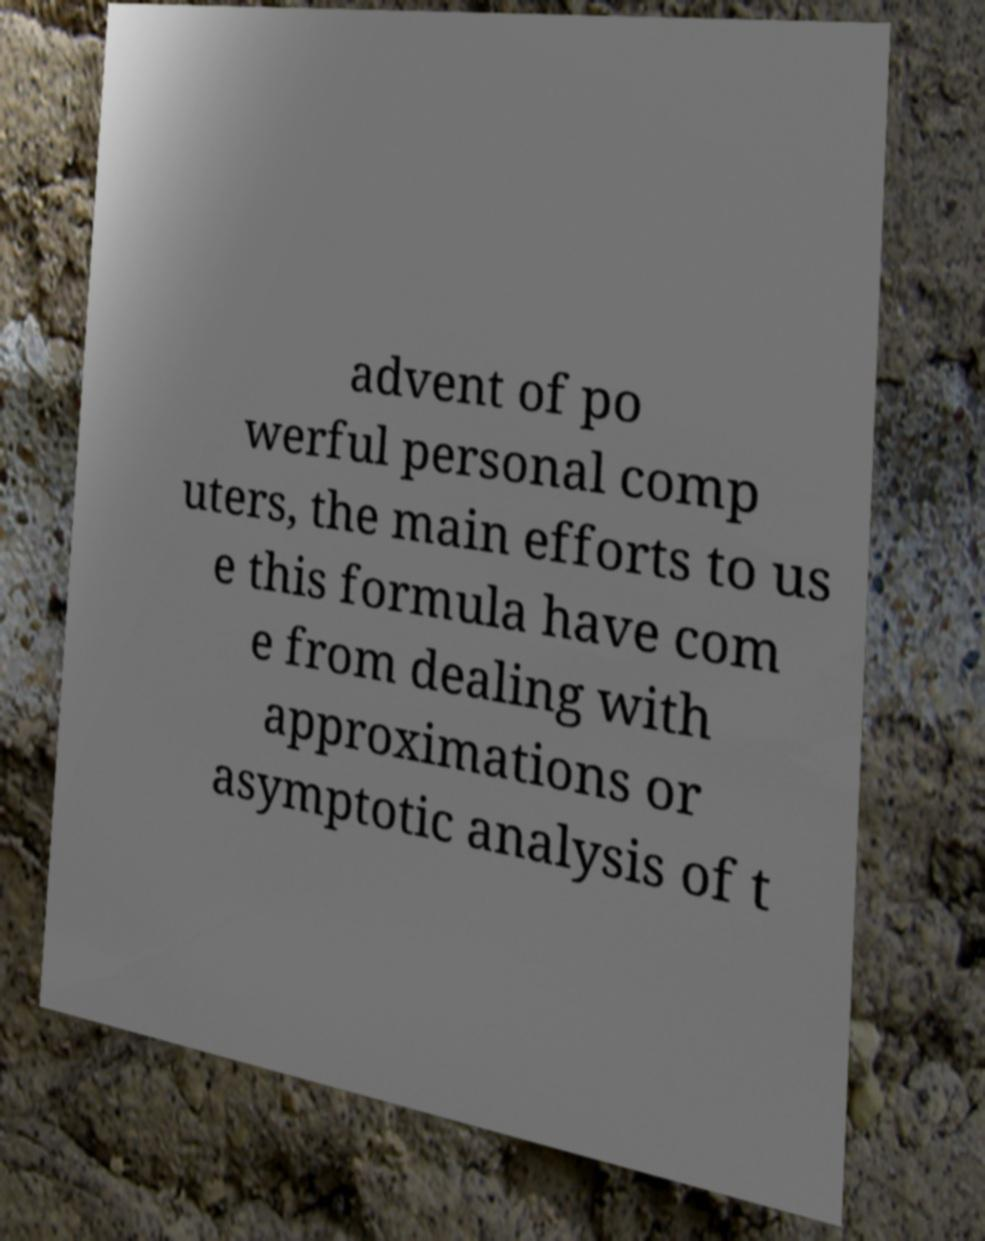For documentation purposes, I need the text within this image transcribed. Could you provide that? advent of po werful personal comp uters, the main efforts to us e this formula have com e from dealing with approximations or asymptotic analysis of t 